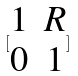Convert formula to latex. <formula><loc_0><loc_0><loc_500><loc_500>[ \begin{matrix} 1 & R \\ 0 & 1 \end{matrix} ]</formula> 